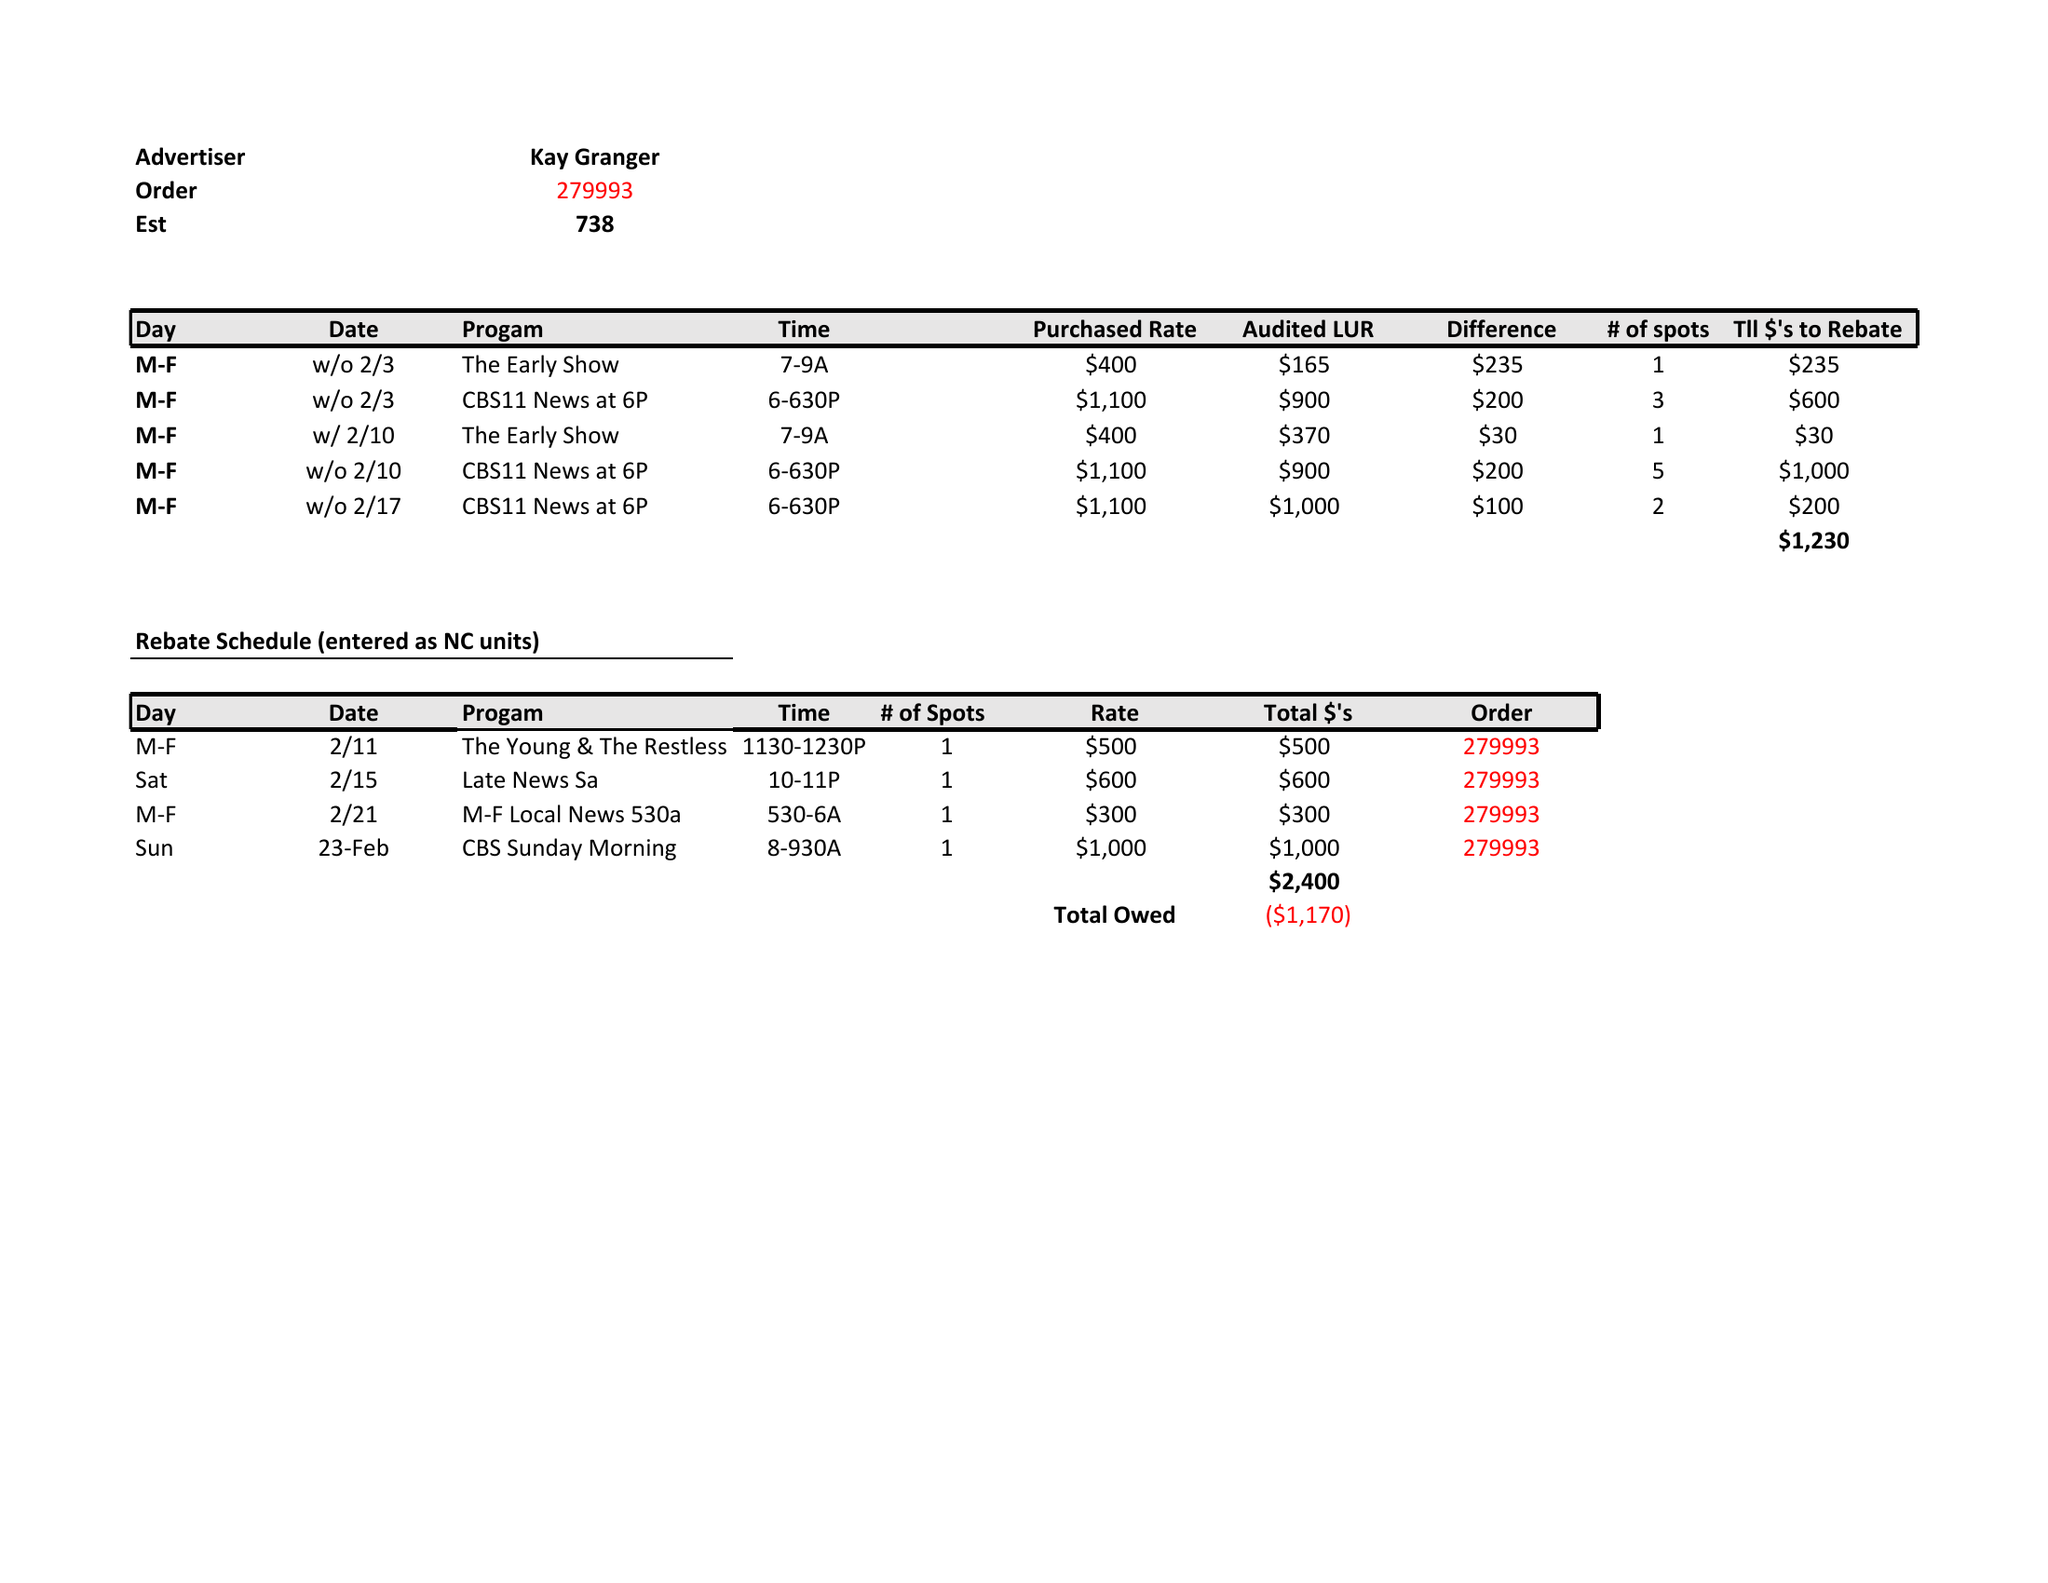What is the value for the gross_amount?
Answer the question using a single word or phrase. None 